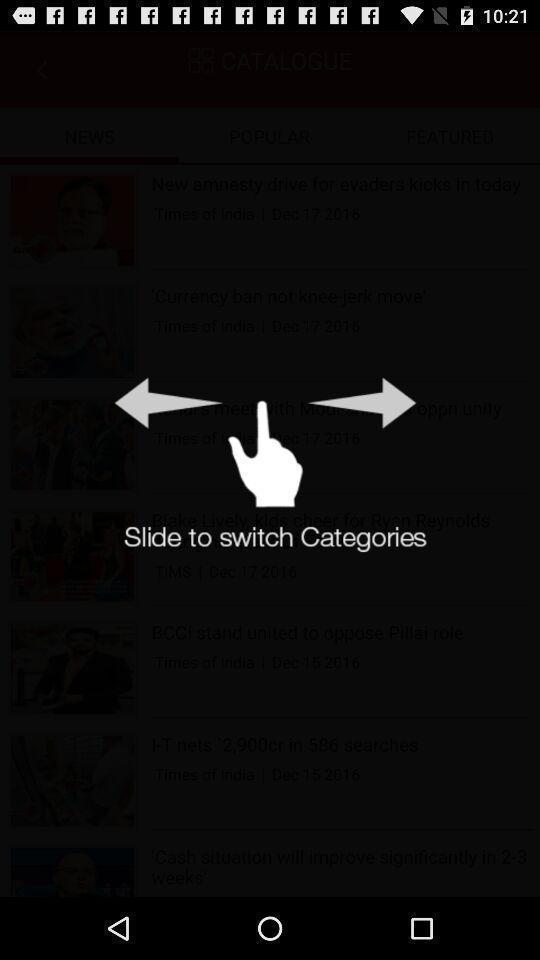Describe the visual elements of this screenshot. Screen showing slide to switch categories. 